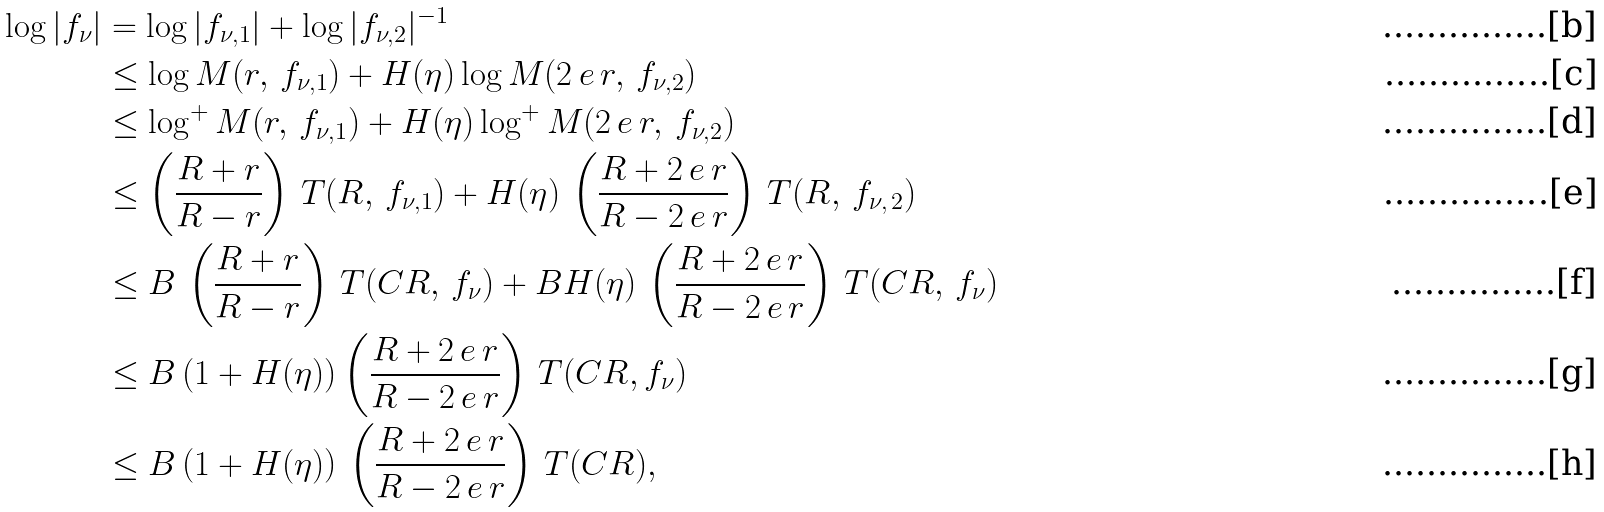<formula> <loc_0><loc_0><loc_500><loc_500>\log | f _ { \nu } | & = \log | f _ { \nu , 1 } | + \log | f _ { \nu , 2 } | ^ { - 1 } \\ & \leq \log M ( r , \, f _ { \nu , 1 } ) + H ( \eta ) \log M ( 2 \, e \, r , \, f _ { \nu , 2 } ) \\ & \leq \log ^ { + } M ( r , \, f _ { \nu , 1 } ) + H ( \eta ) \log ^ { + } M ( 2 \, e \, r , \, f _ { \nu , 2 } ) \\ & \leq \left ( \frac { R + r } { R - r } \right ) \, T ( R , \, f _ { \nu , 1 } ) + H ( \eta ) \, \left ( \frac { R + 2 \, e \, r } { R - 2 \, e \, r } \right ) \, T ( R , \, f _ { \nu , \, 2 } ) \\ & \leq B \, \left ( \frac { R + r } { R - r } \right ) \, T ( C R , \, f _ { \nu } ) + B H ( \eta ) \, \left ( \frac { R + 2 \, e \, r } { R - 2 \, e \, r } \right ) \, T ( C R , \, f _ { \nu } ) \\ & \leq B \left ( 1 + H ( \eta ) \right ) \left ( \frac { R + 2 \, e \, r } { R - 2 \, e \, r } \right ) \, T ( C R , f _ { \nu } ) \\ & \leq B \left ( 1 + H ( \eta ) \right ) \, \left ( \frac { R + 2 \, e \, r } { R - 2 \, e \, r } \right ) \, T ( C R ) ,</formula> 